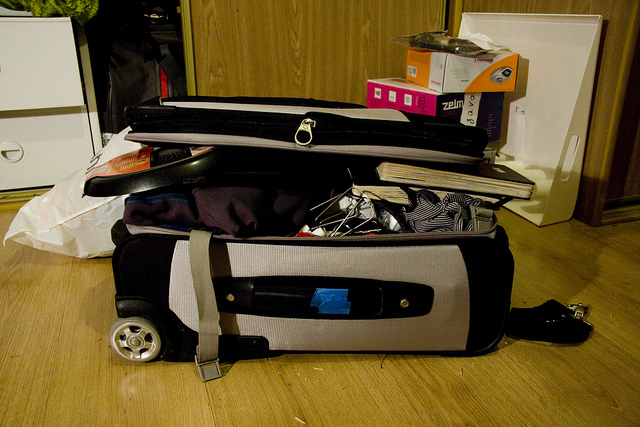<image>What is the purpose of the bow tie on the suitcase? I don't know. The bow tie on the suitcase could serve for decoration, or to help identify it. What is the purpose of the bow tie on the suitcase? I don't know the purpose of the bow tie on the suitcase. It can be for decoration or to identify it. 